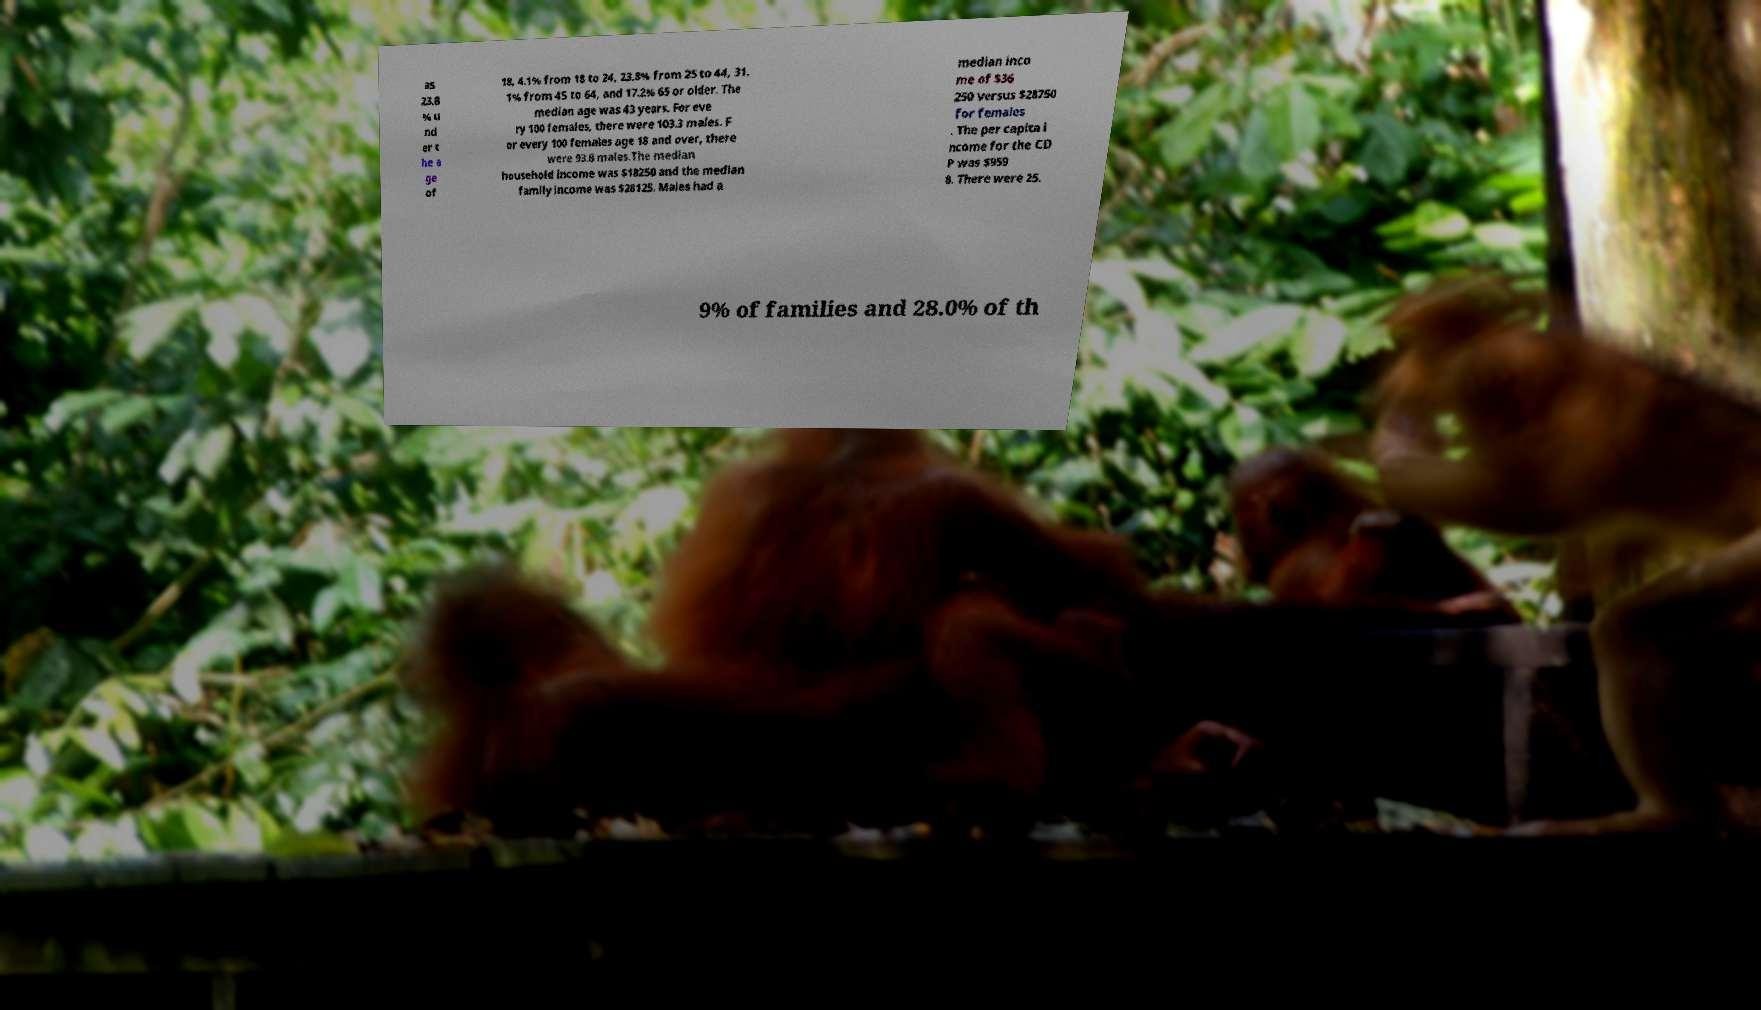Could you assist in decoding the text presented in this image and type it out clearly? as 23.8 % u nd er t he a ge of 18, 4.1% from 18 to 24, 23.8% from 25 to 44, 31. 1% from 45 to 64, and 17.2% 65 or older. The median age was 43 years. For eve ry 100 females, there were 103.3 males. F or every 100 females age 18 and over, there were 93.8 males.The median household income was $18250 and the median family income was $28125. Males had a median inco me of $36 250 versus $28750 for females . The per capita i ncome for the CD P was $959 8. There were 25. 9% of families and 28.0% of th 